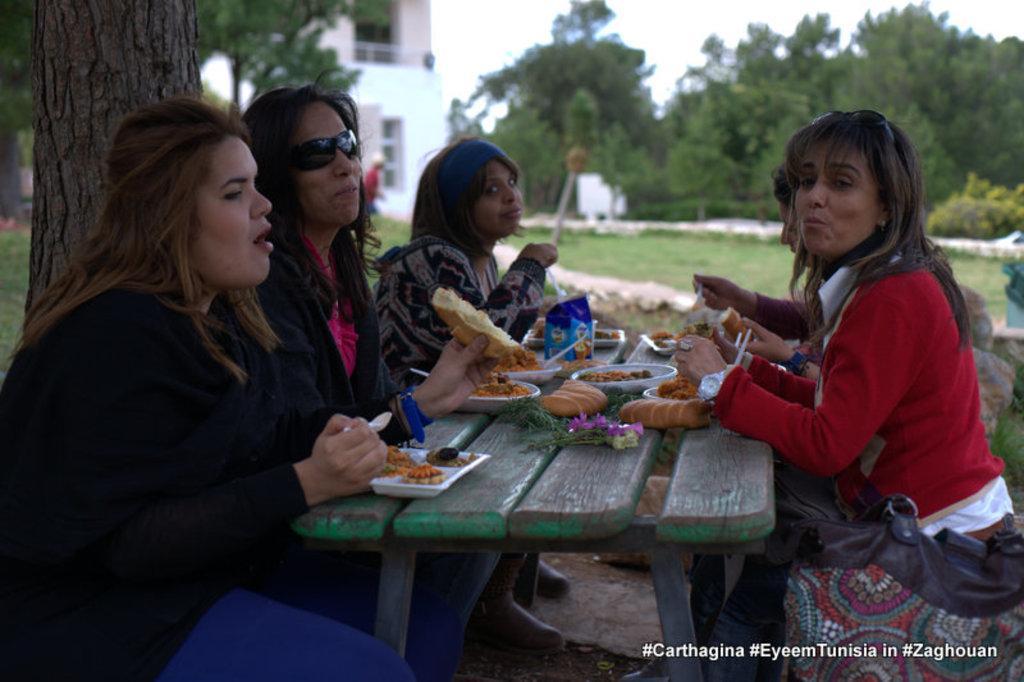In one or two sentences, can you explain what this image depicts? A group of five women are sitting at a table and having food. There are sitting at a tree. There are some trees and building in the background. 